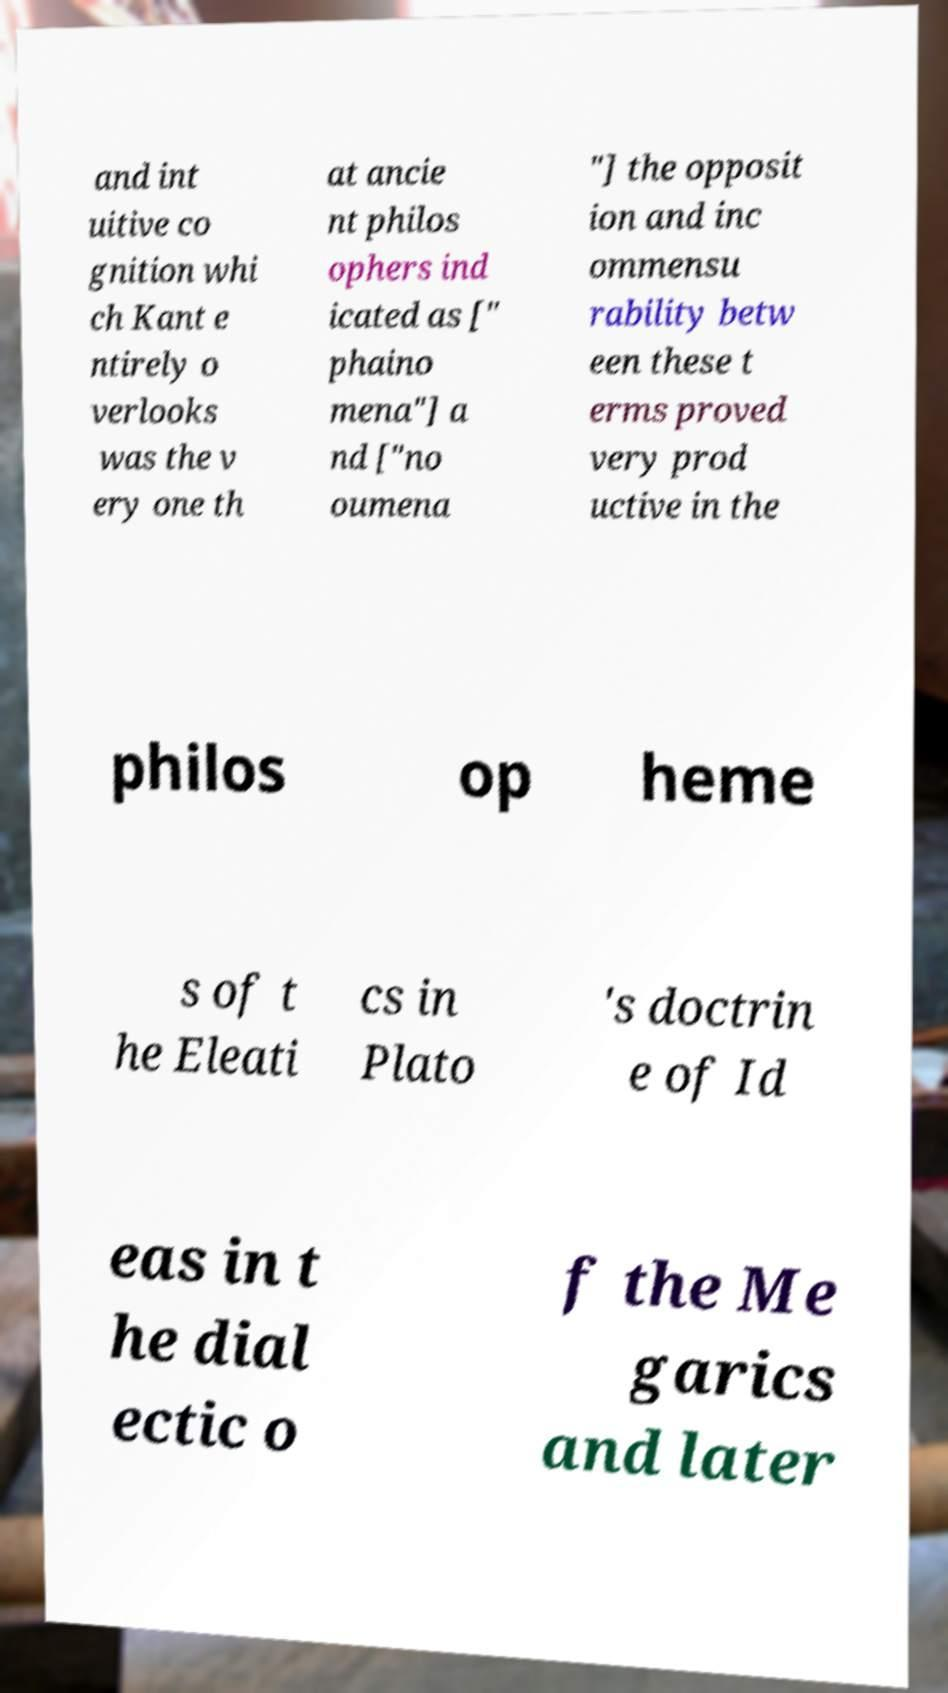For documentation purposes, I need the text within this image transcribed. Could you provide that? and int uitive co gnition whi ch Kant e ntirely o verlooks was the v ery one th at ancie nt philos ophers ind icated as [" phaino mena"] a nd ["no oumena "] the opposit ion and inc ommensu rability betw een these t erms proved very prod uctive in the philos op heme s of t he Eleati cs in Plato 's doctrin e of Id eas in t he dial ectic o f the Me garics and later 